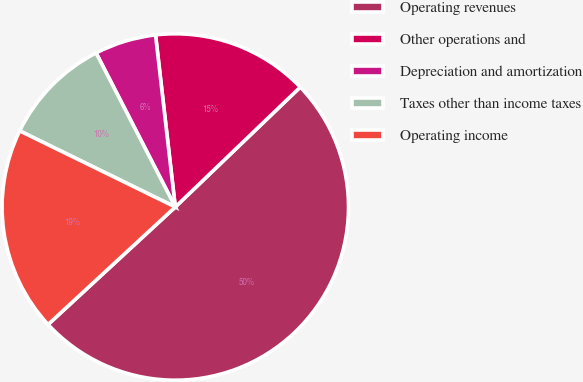<chart> <loc_0><loc_0><loc_500><loc_500><pie_chart><fcel>Operating revenues<fcel>Other operations and<fcel>Depreciation and amortization<fcel>Taxes other than income taxes<fcel>Operating income<nl><fcel>50.3%<fcel>14.65%<fcel>5.74%<fcel>10.2%<fcel>19.11%<nl></chart> 